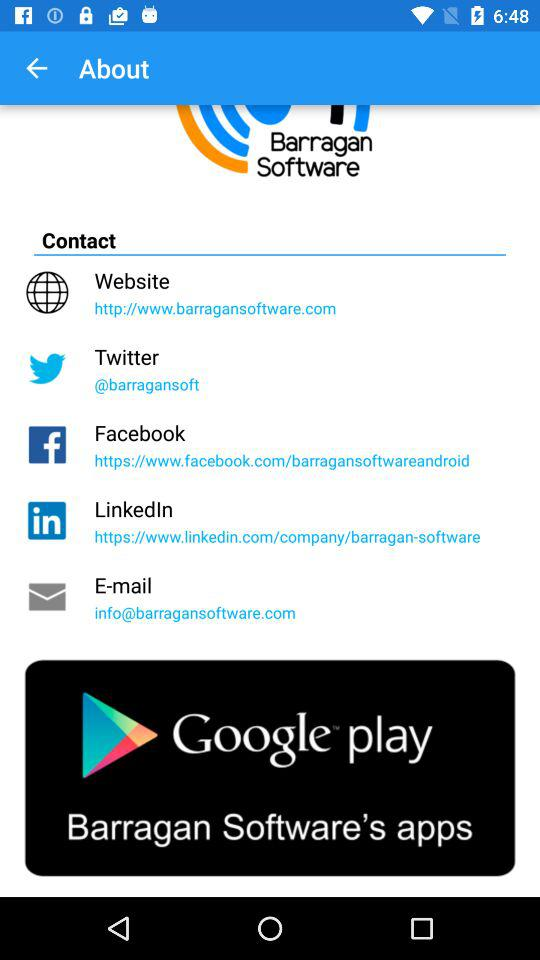What are the ways to "Contact"? The ways are "Website", "Twitter", "Facebook", "LinkedIn", and "E-mail". 